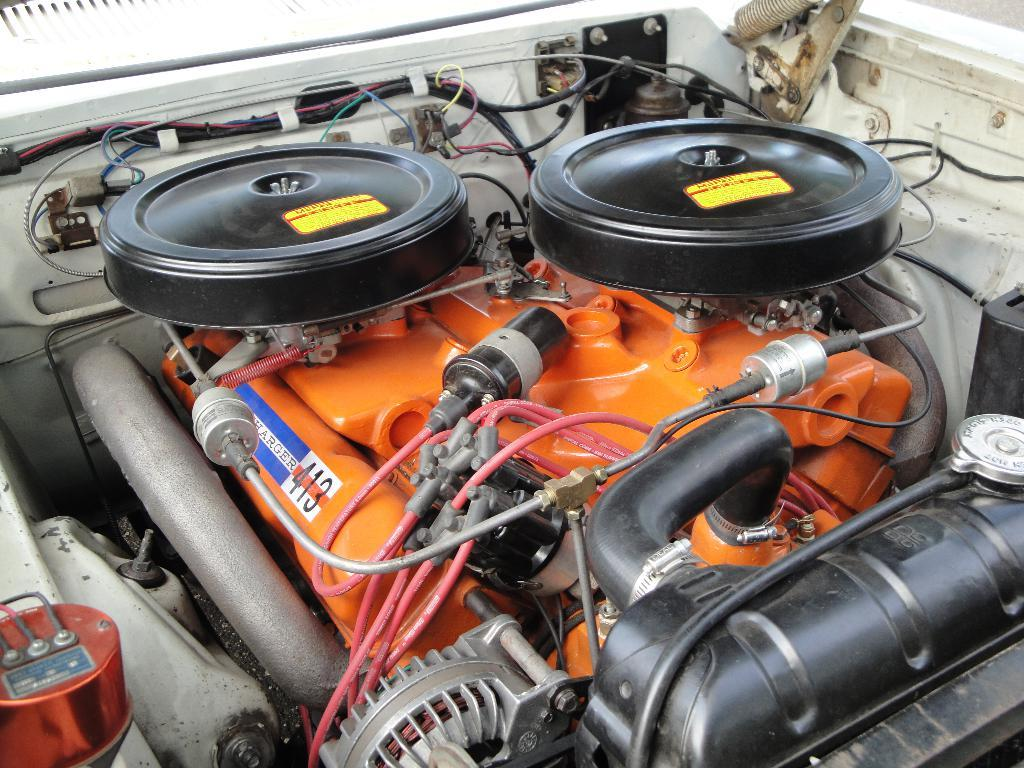What is the main subject in the center of the image? There is a vehicle in the center of the image. What specific features can be seen inside the vehicle? The vehicle contains wires, wheels, and tools. Are there any other objects visible inside the vehicle? Yes, there are other objects visible in the vehicle. How many brothers are sitting in the vehicle in the image? There is no mention of any people, let alone brothers, in the image. The image only shows a vehicle with various features and objects inside. 